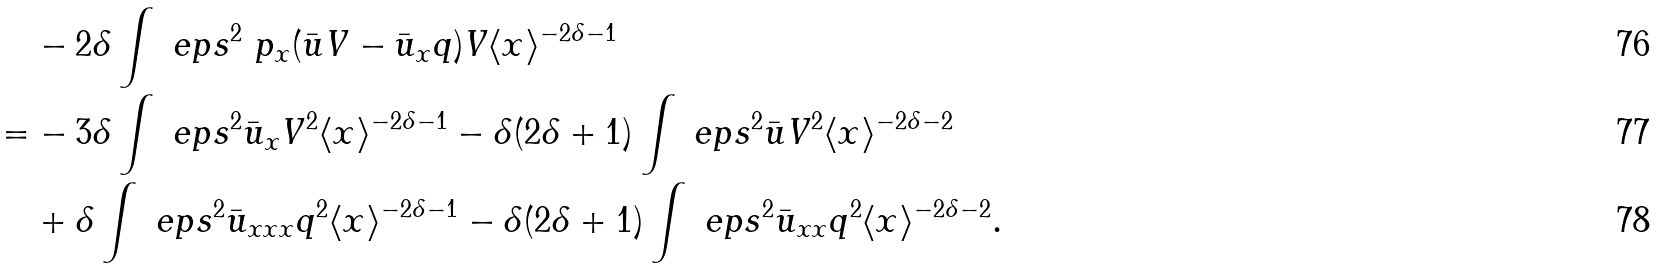Convert formula to latex. <formula><loc_0><loc_0><loc_500><loc_500>& - 2 \delta \int \ e p s ^ { 2 } \ p _ { x } ( \bar { u } V - \bar { u } _ { x } q ) V \langle x \rangle ^ { - 2 \delta - 1 } \\ = & - 3 \delta \int \ e p s ^ { 2 } \bar { u } _ { x } V ^ { 2 } \langle x \rangle ^ { - 2 \delta - 1 } - \delta ( 2 \delta + 1 ) \int \ e p s ^ { 2 } \bar { u } V ^ { 2 } \langle x \rangle ^ { - 2 \delta - 2 } \\ & + \delta \int \ e p s ^ { 2 } \bar { u } _ { x x x } q ^ { 2 } \langle x \rangle ^ { - 2 \delta - 1 } - \delta ( 2 \delta + 1 ) \int \ e p s ^ { 2 } \bar { u } _ { x x } q ^ { 2 } \langle x \rangle ^ { - 2 \delta - 2 } .</formula> 